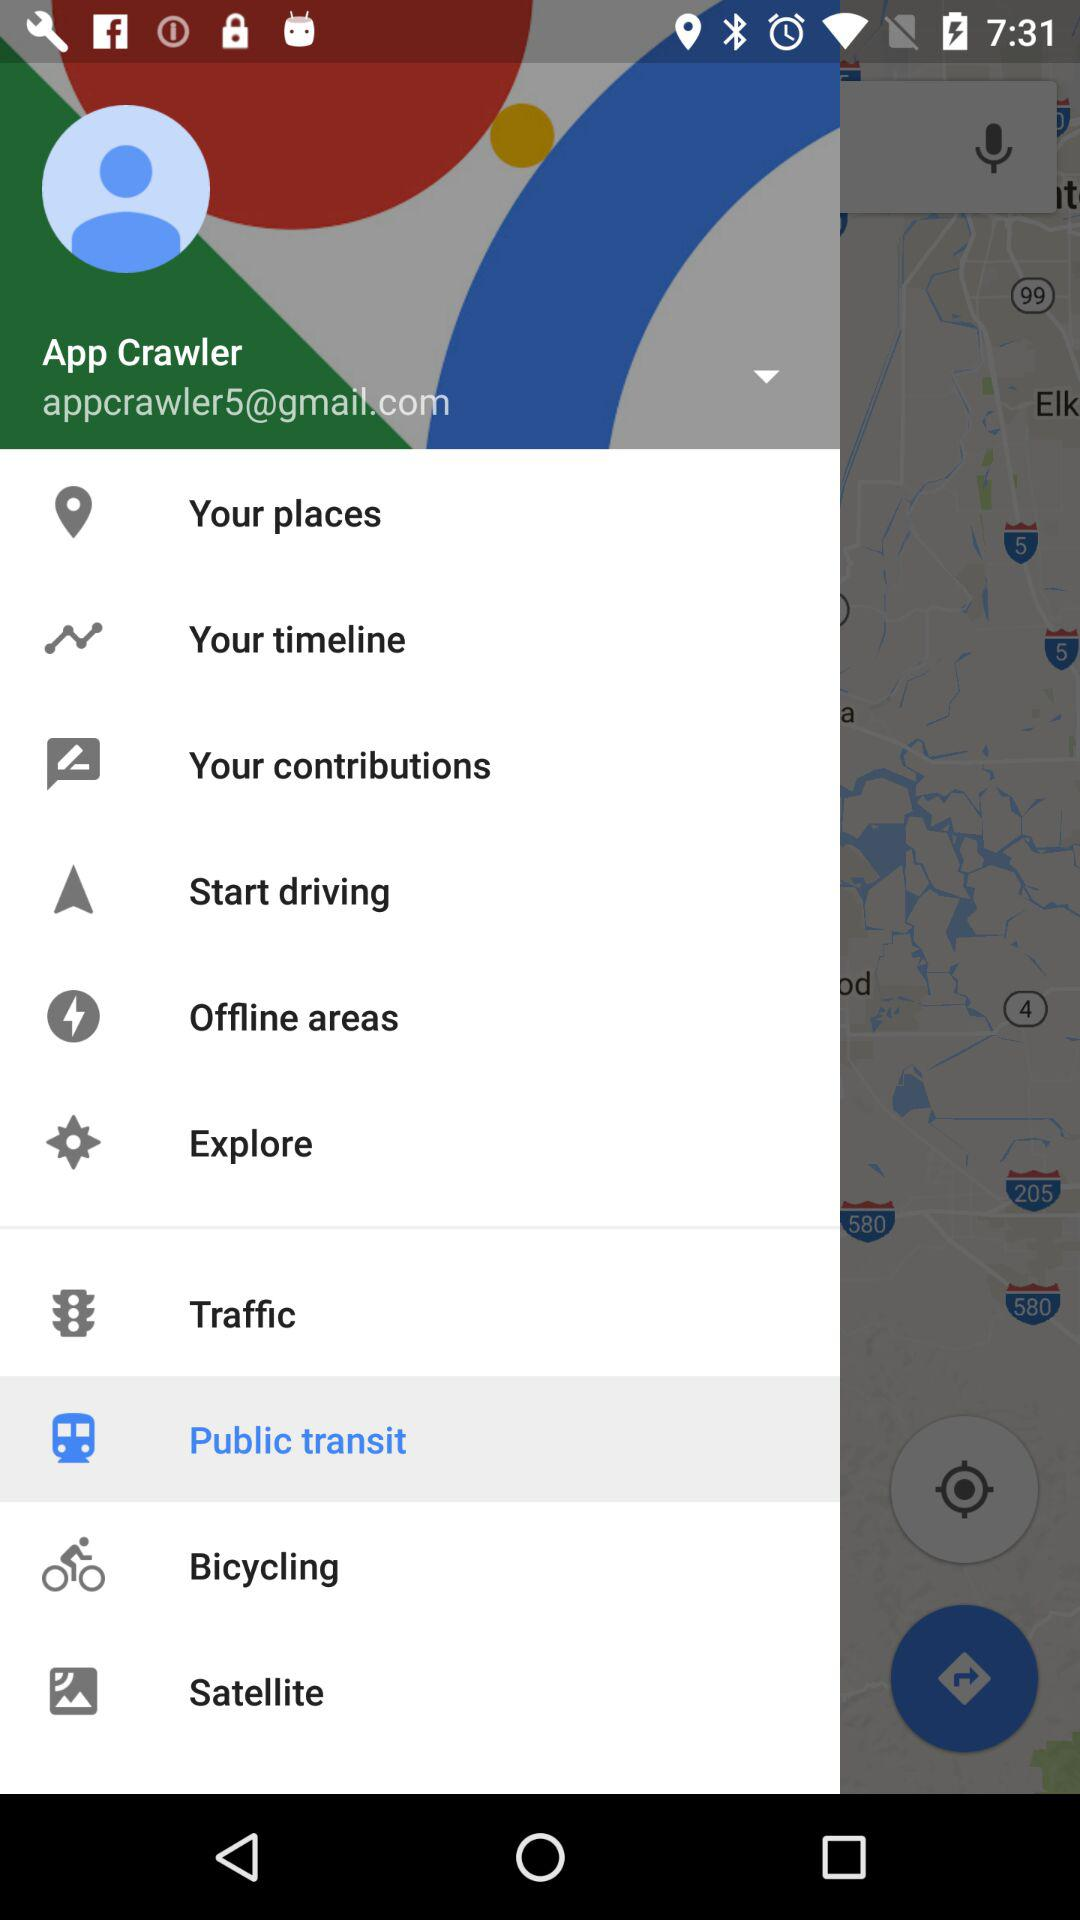Which item is selected? The selected item is "Public transit". 